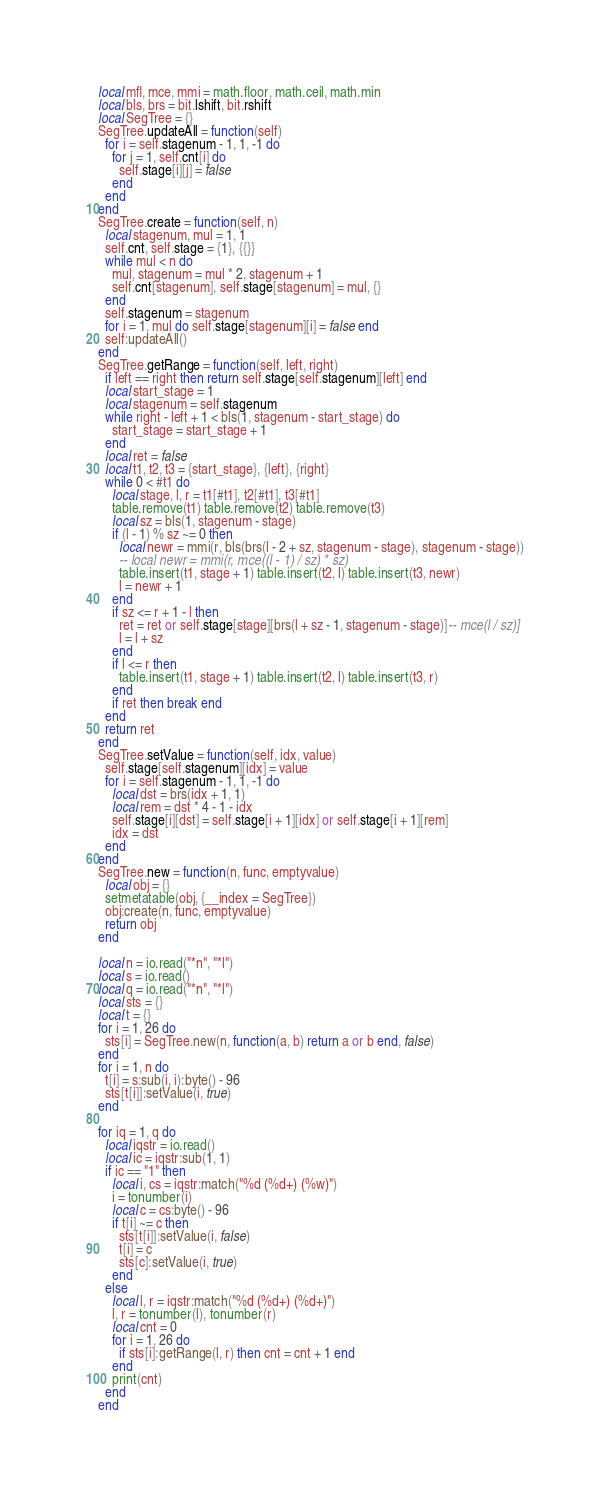Convert code to text. <code><loc_0><loc_0><loc_500><loc_500><_Lua_>local mfl, mce, mmi = math.floor, math.ceil, math.min
local bls, brs = bit.lshift, bit.rshift
local SegTree = {}
SegTree.updateAll = function(self)
  for i = self.stagenum - 1, 1, -1 do
    for j = 1, self.cnt[i] do
      self.stage[i][j] = false
    end
  end
end
SegTree.create = function(self, n)
  local stagenum, mul = 1, 1
  self.cnt, self.stage = {1}, {{}}
  while mul < n do
    mul, stagenum = mul * 2, stagenum + 1
    self.cnt[stagenum], self.stage[stagenum] = mul, {}
  end
  self.stagenum = stagenum
  for i = 1, mul do self.stage[stagenum][i] = false end
  self:updateAll()
end
SegTree.getRange = function(self, left, right)
  if left == right then return self.stage[self.stagenum][left] end
  local start_stage = 1
  local stagenum = self.stagenum
  while right - left + 1 < bls(1, stagenum - start_stage) do
    start_stage = start_stage + 1
  end
  local ret = false
  local t1, t2, t3 = {start_stage}, {left}, {right}
  while 0 < #t1 do
    local stage, l, r = t1[#t1], t2[#t1], t3[#t1]
    table.remove(t1) table.remove(t2) table.remove(t3)
    local sz = bls(1, stagenum - stage)
    if (l - 1) % sz ~= 0 then
      local newr = mmi(r, bls(brs(l - 2 + sz, stagenum - stage), stagenum - stage))
      -- local newr = mmi(r, mce((l - 1) / sz) * sz)
      table.insert(t1, stage + 1) table.insert(t2, l) table.insert(t3, newr)
      l = newr + 1
    end
    if sz <= r + 1 - l then
      ret = ret or self.stage[stage][brs(l + sz - 1, stagenum - stage)]-- mce(l / sz)]
      l = l + sz
    end
    if l <= r then
      table.insert(t1, stage + 1) table.insert(t2, l) table.insert(t3, r)
    end
    if ret then break end
  end
  return ret
end
SegTree.setValue = function(self, idx, value)
  self.stage[self.stagenum][idx] = value
  for i = self.stagenum - 1, 1, -1 do
    local dst = brs(idx + 1, 1)
    local rem = dst * 4 - 1 - idx
    self.stage[i][dst] = self.stage[i + 1][idx] or self.stage[i + 1][rem]
    idx = dst
  end
end
SegTree.new = function(n, func, emptyvalue)
  local obj = {}
  setmetatable(obj, {__index = SegTree})
  obj:create(n, func, emptyvalue)
  return obj
end

local n = io.read("*n", "*l")
local s = io.read()
local q = io.read("*n", "*l")
local sts = {}
local t = {}
for i = 1, 26 do
  sts[i] = SegTree.new(n, function(a, b) return a or b end, false)
end
for i = 1, n do
  t[i] = s:sub(i, i):byte() - 96
  sts[t[i]]:setValue(i, true)
end

for iq = 1, q do
  local iqstr = io.read()
  local ic = iqstr:sub(1, 1)
  if ic == "1" then
    local i, cs = iqstr:match("%d (%d+) (%w)")
    i = tonumber(i)
    local c = cs:byte() - 96
    if t[i] ~= c then
      sts[t[i]]:setValue(i, false)
      t[i] = c
      sts[c]:setValue(i, true)
    end
  else
    local l, r = iqstr:match("%d (%d+) (%d+)")
    l, r = tonumber(l), tonumber(r)
    local cnt = 0
    for i = 1, 26 do
      if sts[i]:getRange(l, r) then cnt = cnt + 1 end
    end
    print(cnt)
  end
end
</code> 